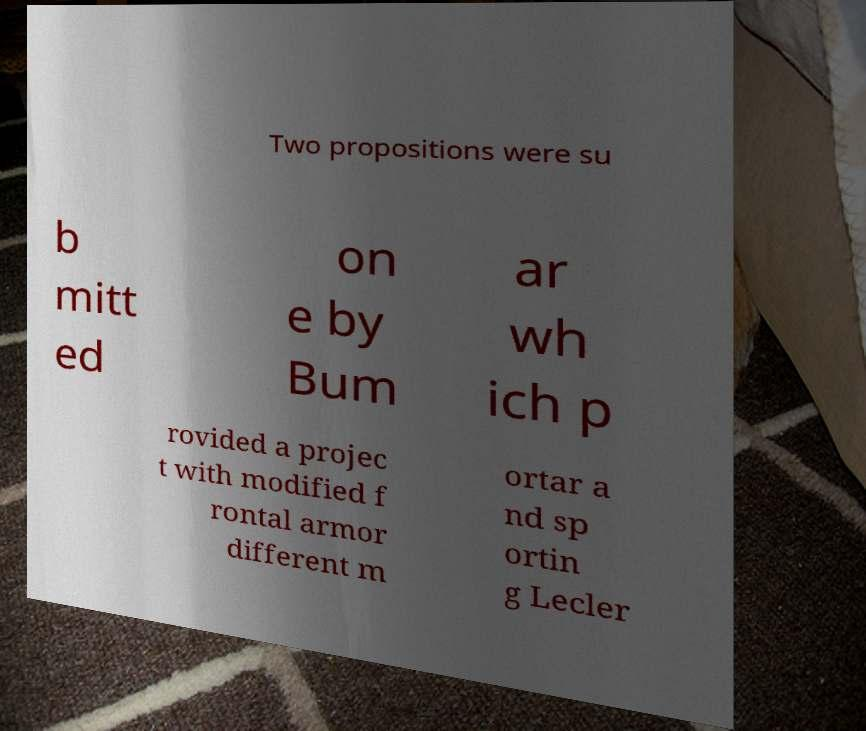Please identify and transcribe the text found in this image. Two propositions were su b mitt ed on e by Bum ar wh ich p rovided a projec t with modified f rontal armor different m ortar a nd sp ortin g Lecler 